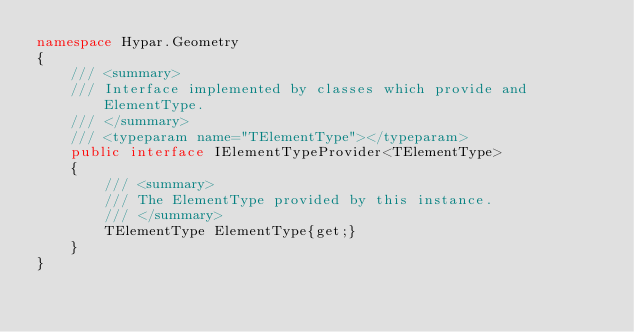Convert code to text. <code><loc_0><loc_0><loc_500><loc_500><_C#_>namespace Hypar.Geometry
{
    /// <summary>
    /// Interface implemented by classes which provide and ElementType.
    /// </summary>
    /// <typeparam name="TElementType"></typeparam>
    public interface IElementTypeProvider<TElementType>
    {
        /// <summary>
        /// The ElementType provided by this instance.
        /// </summary>
        TElementType ElementType{get;}
    }
}</code> 